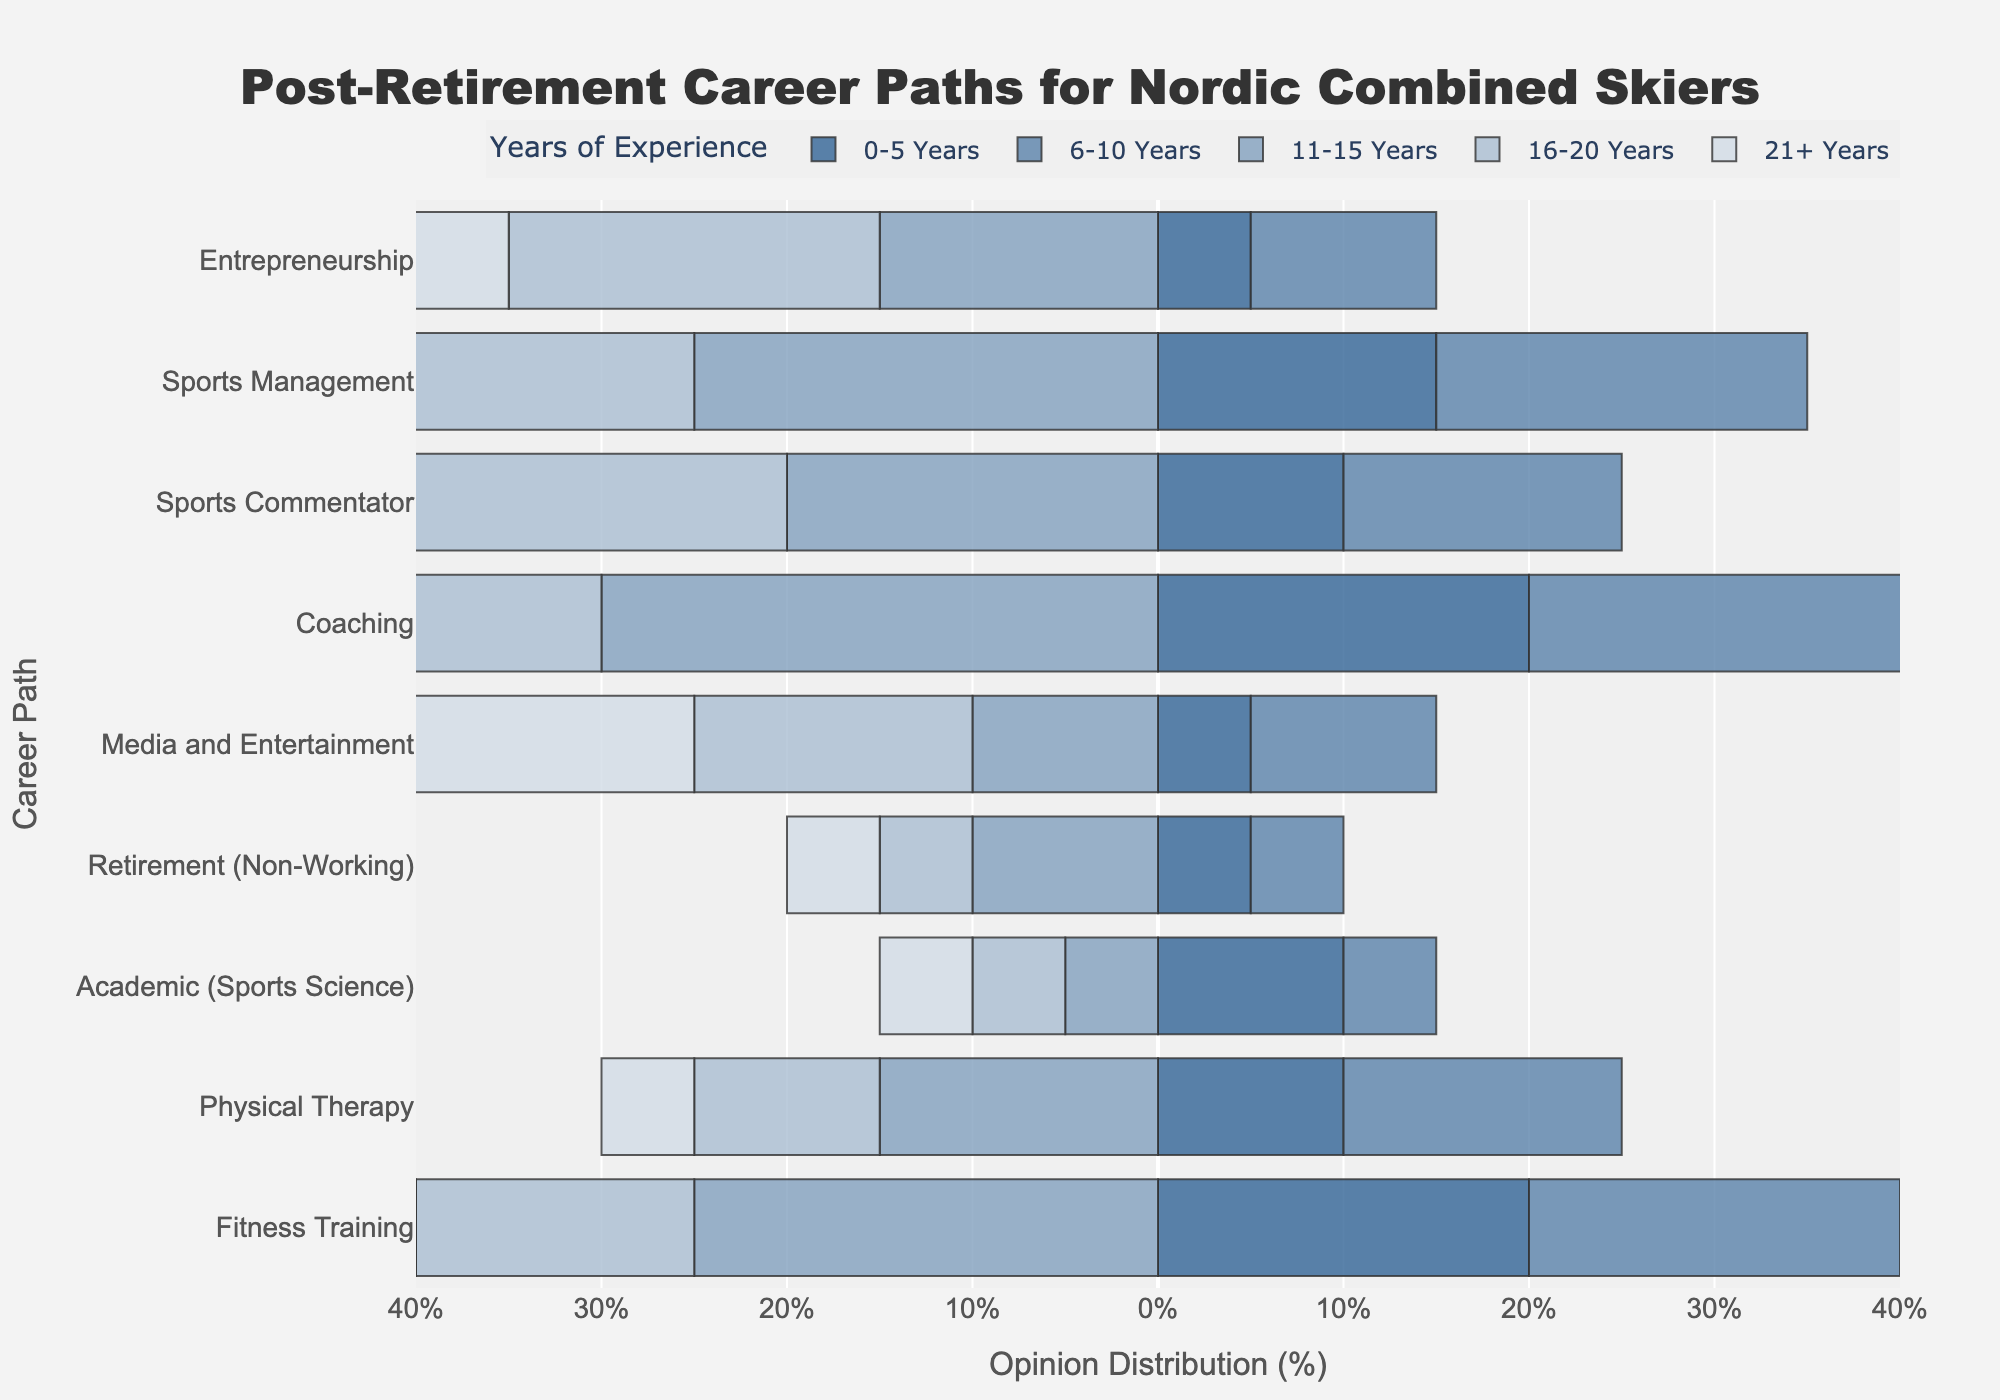What is the most preferred career path among skiers with 0-5 years of experience? The preferred career path is determined by the length of the bar on the positive side of the diverging stacked bar chart for the 0-5 years category. The longest positive bar corresponds to "Coaching."
Answer: Coaching Between “Physical Therapy” and “Fitness Training”, which career path is more preferred by skiers with 11-15 years of experience? Compare the lengths of the bars for 11-15 years of experience corresponding to "Physical Therapy" and "Fitness Training." The bar for "Fitness Training" is longer.
Answer: Fitness Training By how much is the preference for “Sports Commentator” greater than “Media and Entertainment” among skiers with 21+ years of experience? Locate and compare the lengths of the bars for "Sports Commentator" and "Media and Entertainment" in the 21+ years group. The difference in opinion distribution can be calculated by subtracting the percentage for "Media and Entertainment" from the percentage for "Sports Commentator" (30% - 20%).
Answer: 10% What is the least preferred career path among skiers with 16-20 years of experience? To determine the least preferred career path, identify the shortest positive bar in the 16-20 years category. The shortest bar corresponds to "Retirement (Non-Working)."
Answer: Retirement (Non-Working) Which career path has a higher overall preference: “Entrepreneurship” or “Academic (Sports Science)”? To compare the overall preferences, look at the direction and length of the bars for "Entrepreneurship" and "Academic (Sports Science)" across all the experience categories. "Entrepreneurship" generally has longer bars on the positive side than "Academic (Sports Science)."
Answer: Entrepreneurship 